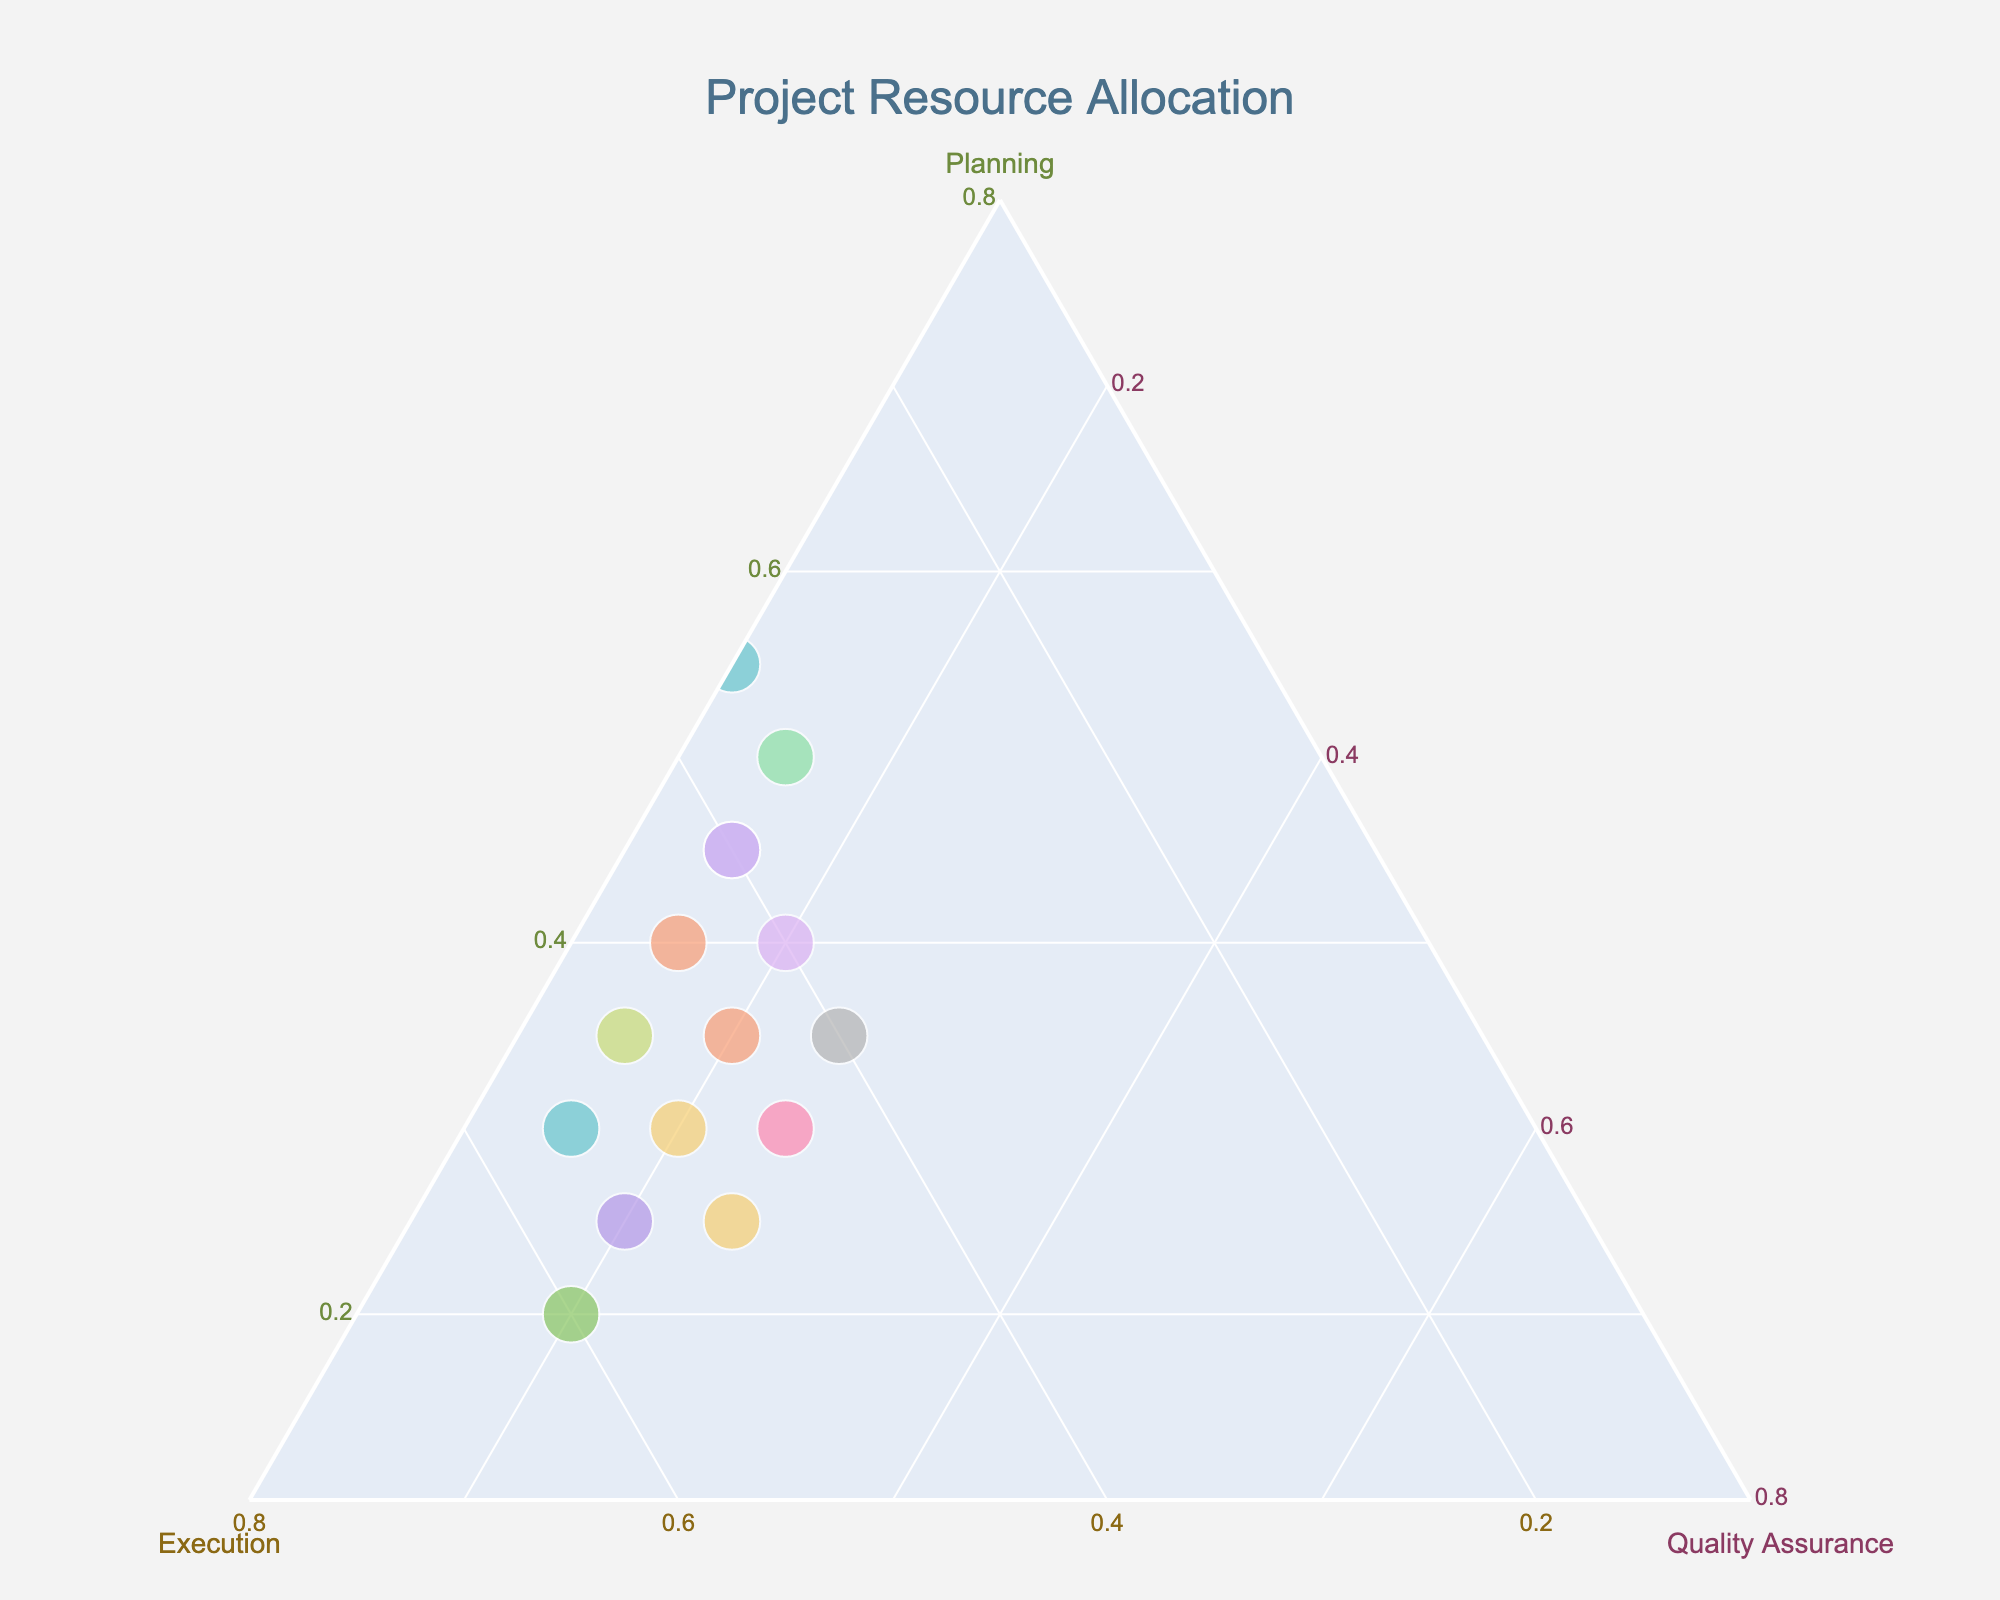What is the title of the plot? The title is usually displayed prominently at the top of the plot. By looking at the center-top area of the plot, we can see the title text.
Answer: Project Resource Allocation How many projects have more than 40% allocated to Planning? Identify points on the plot where the Planning axis indicates a value greater than 0.40 (40%). Count these points.
Answer: 5 Which project has the highest proportion of resources allocated to Execution? Locate the project whose point is closest to the Execution axis apex, indicating maximum allocation to that category.
Answer: Customer Support Improvement What is the sum of the Planning percentages for Employee Training and Team Building Event? Read the Planning percentages for both Employee Training and Team Building Event from the plot, and add them together. Employee Training is 40% and Team Building Event is 55%.
Answer: 95% How do projects varying in Quality Assurance allocation compare in terms of Planning? Examine the distribution along the Quality Assurance axis and compare how these points spread along the Planning axis. Projects with higher Quality Assurance tend to have varying Planning values; some have high and some low Planning percentages, indicating no strong correlation.
Answer: Varied What is the difference in Execution allocation between Sales Strategy and Diversity Initiative? Read the Execution percentages for Sales Strategy and Diversity Initiative from the plot, and subtract one from the other. Sales Strategy is at 50%, and Diversity Initiative is at 35%.
Answer: 15% Which projects have equal Planning and Execution allocations? Identify points on or very close to the line where Planning and Execution percentages are equal. A clear example is Employee Training, with 40% Planning and 40% Execution.
Answer: Employee Training Is there a project with equal resources allocated to Execution and Quality Assurance? Look for a point along the line where the Execution and Quality Assurance values are the same. None of the points fall exactly on this line, suggesting no project has equal Execution and Quality Assurance allocations.
Answer: No What is the average percentage allocated to Planning among all projects? Sum the Planning percentages of all projects and divide by the number of projects (15). The sum of the Planning allocations is 480%. Thus, 480/15 = 32%.
Answer: 32% Among the projects, which one allocates the least resources to Quality Assurance? Find the point closest to the Quality Assurance axis's minimum end. The Team Building Event allocates only 10% to Quality Assurance, the lowest among the listed projects.
Answer: Team Building Event 